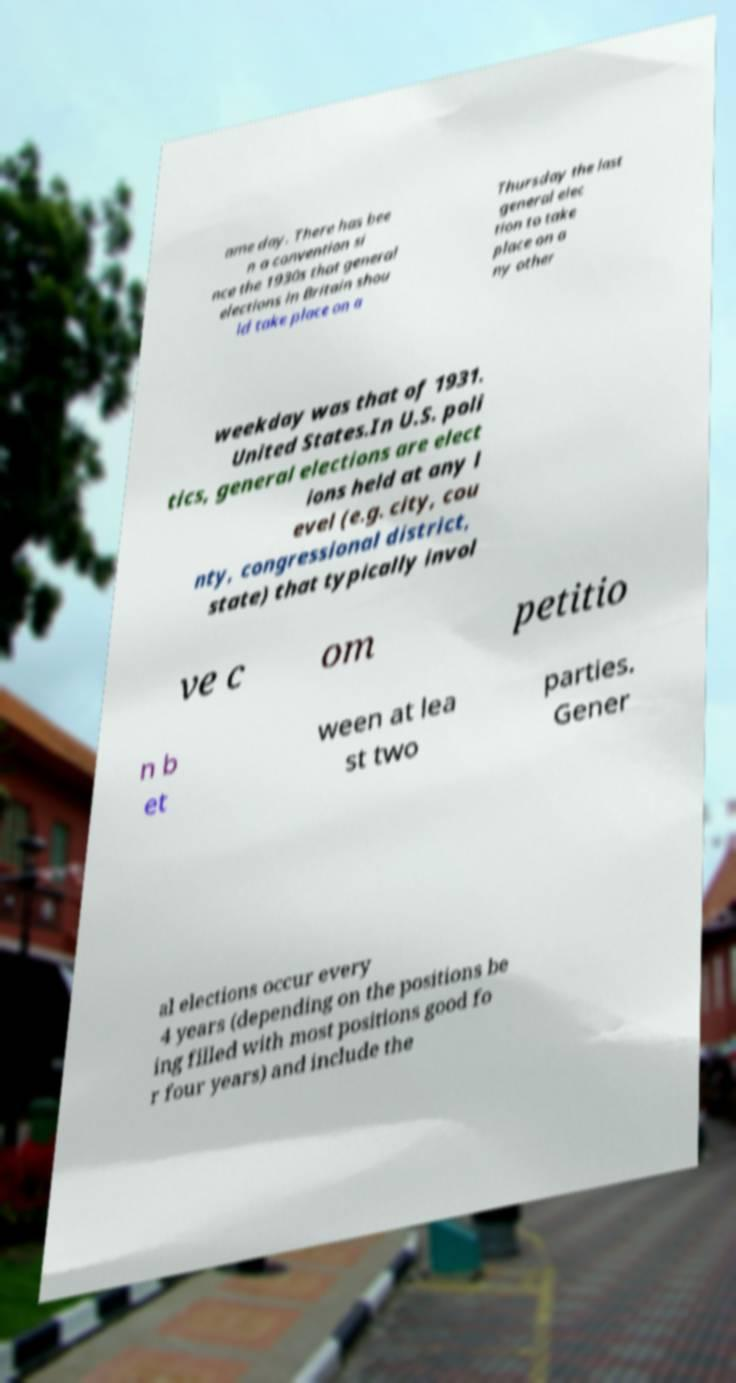Please identify and transcribe the text found in this image. ame day. There has bee n a convention si nce the 1930s that general elections in Britain shou ld take place on a Thursday the last general elec tion to take place on a ny other weekday was that of 1931. United States.In U.S. poli tics, general elections are elect ions held at any l evel (e.g. city, cou nty, congressional district, state) that typically invol ve c om petitio n b et ween at lea st two parties. Gener al elections occur every 4 years (depending on the positions be ing filled with most positions good fo r four years) and include the 